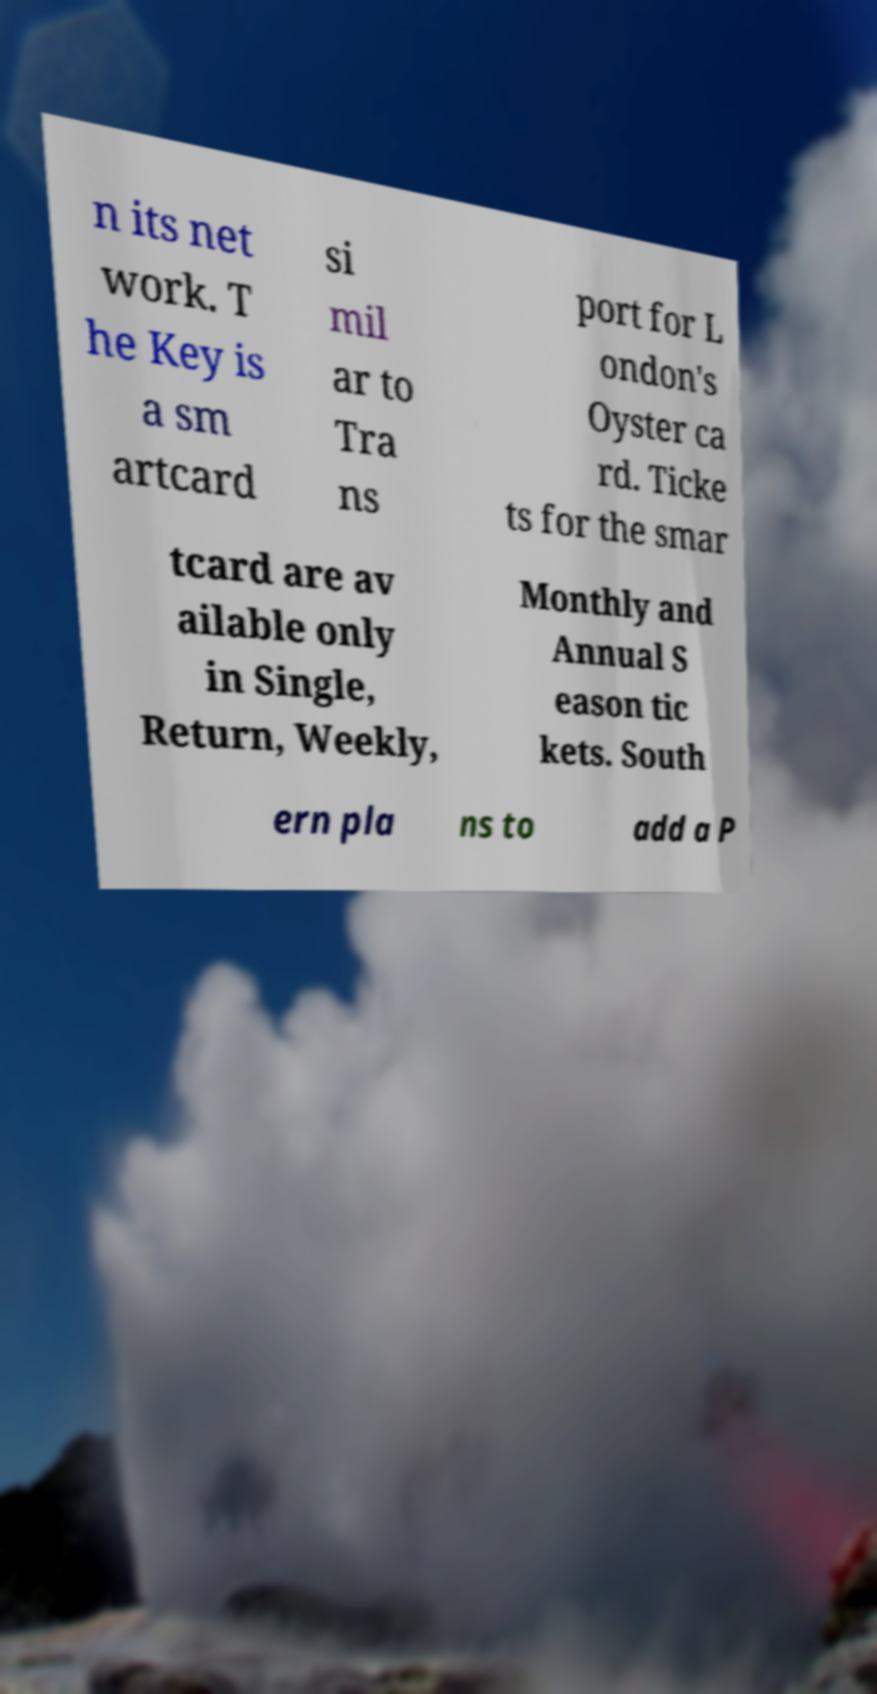What messages or text are displayed in this image? I need them in a readable, typed format. n its net work. T he Key is a sm artcard si mil ar to Tra ns port for L ondon's Oyster ca rd. Ticke ts for the smar tcard are av ailable only in Single, Return, Weekly, Monthly and Annual S eason tic kets. South ern pla ns to add a P 